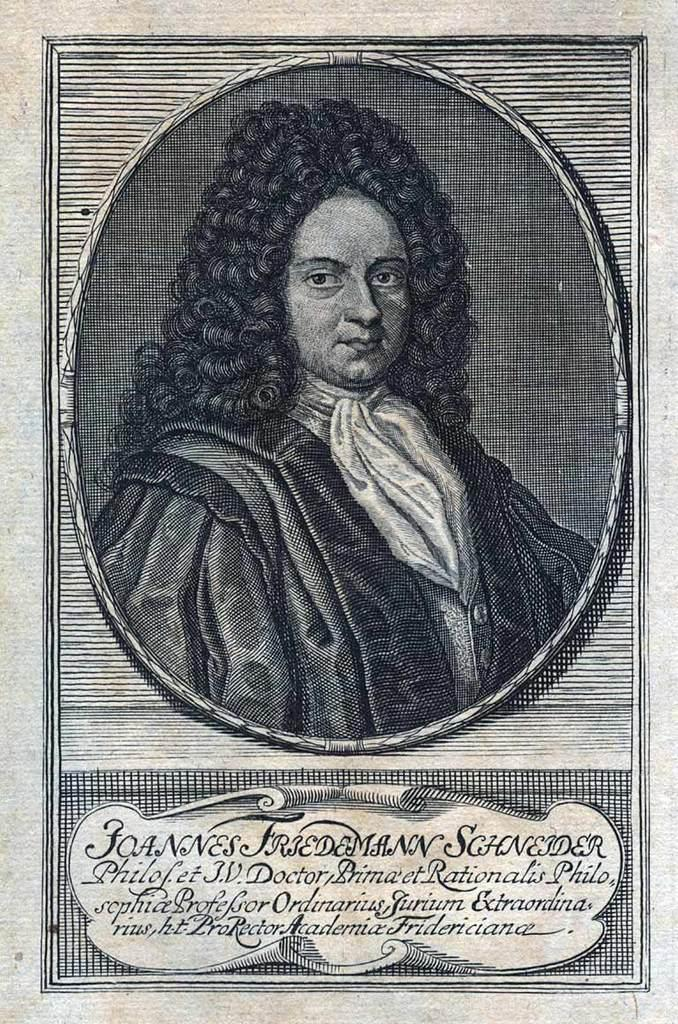<image>
Present a compact description of the photo's key features. A picture of Joannes Friedemann Schneider drawn back in the day. 